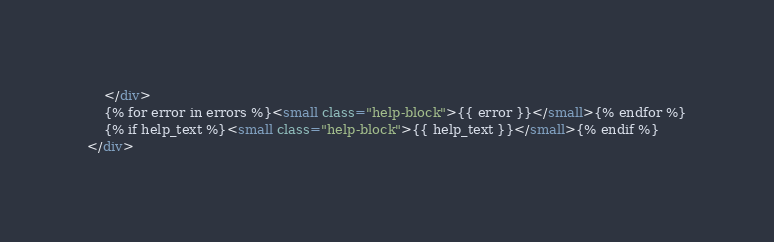<code> <loc_0><loc_0><loc_500><loc_500><_HTML_>    </div>
    {% for error in errors %}<small class="help-block">{{ error }}</small>{% endfor %}
    {% if help_text %}<small class="help-block">{{ help_text }}</small>{% endif %}
</div>
</code> 